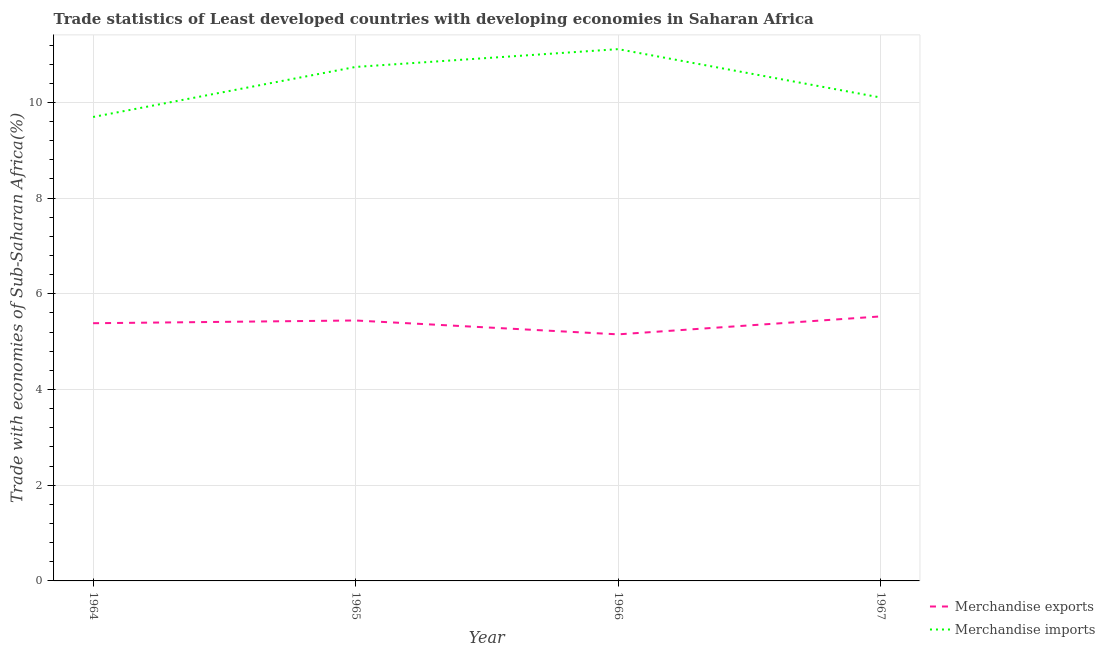How many different coloured lines are there?
Make the answer very short. 2. Does the line corresponding to merchandise exports intersect with the line corresponding to merchandise imports?
Provide a short and direct response. No. What is the merchandise exports in 1964?
Ensure brevity in your answer.  5.39. Across all years, what is the maximum merchandise imports?
Ensure brevity in your answer.  11.11. Across all years, what is the minimum merchandise imports?
Ensure brevity in your answer.  9.7. In which year was the merchandise exports maximum?
Give a very brief answer. 1967. In which year was the merchandise imports minimum?
Offer a terse response. 1964. What is the total merchandise imports in the graph?
Your response must be concise. 41.65. What is the difference between the merchandise exports in 1965 and that in 1966?
Your answer should be very brief. 0.29. What is the difference between the merchandise imports in 1966 and the merchandise exports in 1965?
Keep it short and to the point. 5.67. What is the average merchandise exports per year?
Offer a very short reply. 5.38. In the year 1964, what is the difference between the merchandise imports and merchandise exports?
Keep it short and to the point. 4.31. In how many years, is the merchandise imports greater than 7.6 %?
Ensure brevity in your answer.  4. What is the ratio of the merchandise exports in 1964 to that in 1965?
Your response must be concise. 0.99. Is the merchandise exports in 1965 less than that in 1967?
Offer a very short reply. Yes. Is the difference between the merchandise imports in 1965 and 1967 greater than the difference between the merchandise exports in 1965 and 1967?
Your response must be concise. Yes. What is the difference between the highest and the second highest merchandise imports?
Provide a succinct answer. 0.37. What is the difference between the highest and the lowest merchandise imports?
Offer a terse response. 1.42. Is the sum of the merchandise imports in 1964 and 1966 greater than the maximum merchandise exports across all years?
Your response must be concise. Yes. How many years are there in the graph?
Your response must be concise. 4. Does the graph contain any zero values?
Give a very brief answer. No. Does the graph contain grids?
Make the answer very short. Yes. Where does the legend appear in the graph?
Your answer should be very brief. Bottom right. What is the title of the graph?
Make the answer very short. Trade statistics of Least developed countries with developing economies in Saharan Africa. Does "Public credit registry" appear as one of the legend labels in the graph?
Your response must be concise. No. What is the label or title of the X-axis?
Give a very brief answer. Year. What is the label or title of the Y-axis?
Provide a short and direct response. Trade with economies of Sub-Saharan Africa(%). What is the Trade with economies of Sub-Saharan Africa(%) in Merchandise exports in 1964?
Your answer should be compact. 5.39. What is the Trade with economies of Sub-Saharan Africa(%) of Merchandise imports in 1964?
Offer a very short reply. 9.7. What is the Trade with economies of Sub-Saharan Africa(%) in Merchandise exports in 1965?
Your answer should be compact. 5.44. What is the Trade with economies of Sub-Saharan Africa(%) in Merchandise imports in 1965?
Offer a terse response. 10.74. What is the Trade with economies of Sub-Saharan Africa(%) of Merchandise exports in 1966?
Offer a very short reply. 5.15. What is the Trade with economies of Sub-Saharan Africa(%) in Merchandise imports in 1966?
Your answer should be compact. 11.11. What is the Trade with economies of Sub-Saharan Africa(%) in Merchandise exports in 1967?
Your response must be concise. 5.53. What is the Trade with economies of Sub-Saharan Africa(%) of Merchandise imports in 1967?
Provide a succinct answer. 10.1. Across all years, what is the maximum Trade with economies of Sub-Saharan Africa(%) in Merchandise exports?
Give a very brief answer. 5.53. Across all years, what is the maximum Trade with economies of Sub-Saharan Africa(%) of Merchandise imports?
Your answer should be compact. 11.11. Across all years, what is the minimum Trade with economies of Sub-Saharan Africa(%) of Merchandise exports?
Offer a very short reply. 5.15. Across all years, what is the minimum Trade with economies of Sub-Saharan Africa(%) of Merchandise imports?
Your answer should be compact. 9.7. What is the total Trade with economies of Sub-Saharan Africa(%) of Merchandise exports in the graph?
Ensure brevity in your answer.  21.51. What is the total Trade with economies of Sub-Saharan Africa(%) of Merchandise imports in the graph?
Make the answer very short. 41.65. What is the difference between the Trade with economies of Sub-Saharan Africa(%) in Merchandise exports in 1964 and that in 1965?
Offer a very short reply. -0.06. What is the difference between the Trade with economies of Sub-Saharan Africa(%) in Merchandise imports in 1964 and that in 1965?
Ensure brevity in your answer.  -1.05. What is the difference between the Trade with economies of Sub-Saharan Africa(%) of Merchandise exports in 1964 and that in 1966?
Make the answer very short. 0.23. What is the difference between the Trade with economies of Sub-Saharan Africa(%) of Merchandise imports in 1964 and that in 1966?
Give a very brief answer. -1.42. What is the difference between the Trade with economies of Sub-Saharan Africa(%) in Merchandise exports in 1964 and that in 1967?
Your answer should be compact. -0.14. What is the difference between the Trade with economies of Sub-Saharan Africa(%) in Merchandise imports in 1964 and that in 1967?
Keep it short and to the point. -0.41. What is the difference between the Trade with economies of Sub-Saharan Africa(%) of Merchandise exports in 1965 and that in 1966?
Offer a terse response. 0.29. What is the difference between the Trade with economies of Sub-Saharan Africa(%) in Merchandise imports in 1965 and that in 1966?
Keep it short and to the point. -0.37. What is the difference between the Trade with economies of Sub-Saharan Africa(%) of Merchandise exports in 1965 and that in 1967?
Offer a terse response. -0.09. What is the difference between the Trade with economies of Sub-Saharan Africa(%) in Merchandise imports in 1965 and that in 1967?
Ensure brevity in your answer.  0.64. What is the difference between the Trade with economies of Sub-Saharan Africa(%) of Merchandise exports in 1966 and that in 1967?
Your answer should be very brief. -0.38. What is the difference between the Trade with economies of Sub-Saharan Africa(%) in Merchandise imports in 1966 and that in 1967?
Provide a short and direct response. 1.01. What is the difference between the Trade with economies of Sub-Saharan Africa(%) of Merchandise exports in 1964 and the Trade with economies of Sub-Saharan Africa(%) of Merchandise imports in 1965?
Your response must be concise. -5.36. What is the difference between the Trade with economies of Sub-Saharan Africa(%) in Merchandise exports in 1964 and the Trade with economies of Sub-Saharan Africa(%) in Merchandise imports in 1966?
Provide a succinct answer. -5.73. What is the difference between the Trade with economies of Sub-Saharan Africa(%) in Merchandise exports in 1964 and the Trade with economies of Sub-Saharan Africa(%) in Merchandise imports in 1967?
Provide a succinct answer. -4.72. What is the difference between the Trade with economies of Sub-Saharan Africa(%) in Merchandise exports in 1965 and the Trade with economies of Sub-Saharan Africa(%) in Merchandise imports in 1966?
Provide a short and direct response. -5.67. What is the difference between the Trade with economies of Sub-Saharan Africa(%) of Merchandise exports in 1965 and the Trade with economies of Sub-Saharan Africa(%) of Merchandise imports in 1967?
Offer a terse response. -4.66. What is the difference between the Trade with economies of Sub-Saharan Africa(%) in Merchandise exports in 1966 and the Trade with economies of Sub-Saharan Africa(%) in Merchandise imports in 1967?
Provide a short and direct response. -4.95. What is the average Trade with economies of Sub-Saharan Africa(%) of Merchandise exports per year?
Ensure brevity in your answer.  5.38. What is the average Trade with economies of Sub-Saharan Africa(%) in Merchandise imports per year?
Your answer should be compact. 10.41. In the year 1964, what is the difference between the Trade with economies of Sub-Saharan Africa(%) of Merchandise exports and Trade with economies of Sub-Saharan Africa(%) of Merchandise imports?
Offer a terse response. -4.31. In the year 1965, what is the difference between the Trade with economies of Sub-Saharan Africa(%) of Merchandise exports and Trade with economies of Sub-Saharan Africa(%) of Merchandise imports?
Provide a succinct answer. -5.3. In the year 1966, what is the difference between the Trade with economies of Sub-Saharan Africa(%) in Merchandise exports and Trade with economies of Sub-Saharan Africa(%) in Merchandise imports?
Keep it short and to the point. -5.96. In the year 1967, what is the difference between the Trade with economies of Sub-Saharan Africa(%) in Merchandise exports and Trade with economies of Sub-Saharan Africa(%) in Merchandise imports?
Keep it short and to the point. -4.57. What is the ratio of the Trade with economies of Sub-Saharan Africa(%) in Merchandise imports in 1964 to that in 1965?
Provide a succinct answer. 0.9. What is the ratio of the Trade with economies of Sub-Saharan Africa(%) in Merchandise exports in 1964 to that in 1966?
Offer a very short reply. 1.05. What is the ratio of the Trade with economies of Sub-Saharan Africa(%) in Merchandise imports in 1964 to that in 1966?
Keep it short and to the point. 0.87. What is the ratio of the Trade with economies of Sub-Saharan Africa(%) of Merchandise exports in 1964 to that in 1967?
Your answer should be compact. 0.97. What is the ratio of the Trade with economies of Sub-Saharan Africa(%) in Merchandise imports in 1964 to that in 1967?
Offer a terse response. 0.96. What is the ratio of the Trade with economies of Sub-Saharan Africa(%) in Merchandise exports in 1965 to that in 1966?
Give a very brief answer. 1.06. What is the ratio of the Trade with economies of Sub-Saharan Africa(%) of Merchandise imports in 1965 to that in 1966?
Give a very brief answer. 0.97. What is the ratio of the Trade with economies of Sub-Saharan Africa(%) of Merchandise exports in 1965 to that in 1967?
Offer a terse response. 0.98. What is the ratio of the Trade with economies of Sub-Saharan Africa(%) in Merchandise imports in 1965 to that in 1967?
Your response must be concise. 1.06. What is the ratio of the Trade with economies of Sub-Saharan Africa(%) in Merchandise exports in 1966 to that in 1967?
Your answer should be compact. 0.93. What is the ratio of the Trade with economies of Sub-Saharan Africa(%) in Merchandise imports in 1966 to that in 1967?
Your answer should be compact. 1.1. What is the difference between the highest and the second highest Trade with economies of Sub-Saharan Africa(%) in Merchandise exports?
Provide a short and direct response. 0.09. What is the difference between the highest and the second highest Trade with economies of Sub-Saharan Africa(%) in Merchandise imports?
Offer a very short reply. 0.37. What is the difference between the highest and the lowest Trade with economies of Sub-Saharan Africa(%) of Merchandise exports?
Ensure brevity in your answer.  0.38. What is the difference between the highest and the lowest Trade with economies of Sub-Saharan Africa(%) in Merchandise imports?
Make the answer very short. 1.42. 